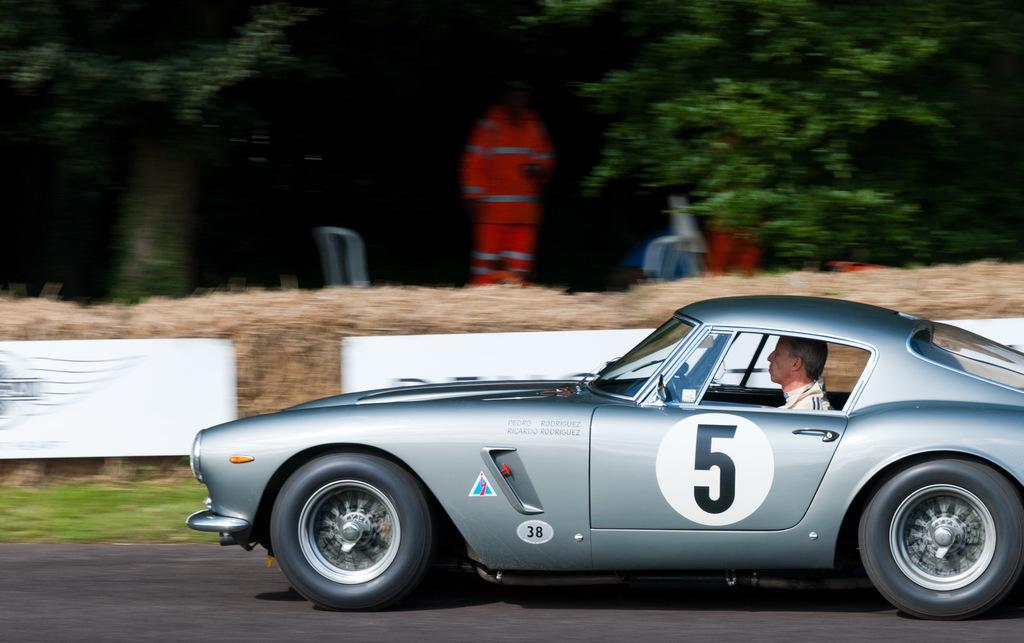What is the main subject of the image? The main subject of the image is a car. Who or what is inside the car? A person is sitting inside the car. What type of setting is depicted in the image? The image depicts a road. What type of vegetation is present in the image? Grass is present in the image. Are there any other people visible in the image? Yes, there are people standing and watching in the image. What type of rod can be seen in the image? There is no rod present in the image. How many cracks are visible in the image? There are no cracks visible in the image. 